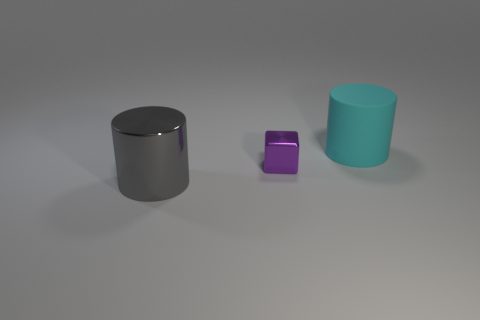Subtract all red blocks. Subtract all yellow cylinders. How many blocks are left? 1 Add 1 small cyan matte blocks. How many objects exist? 4 Subtract all blocks. How many objects are left? 2 Add 2 cylinders. How many cylinders exist? 4 Subtract 0 blue balls. How many objects are left? 3 Subtract all rubber objects. Subtract all small metal cubes. How many objects are left? 1 Add 1 metallic cylinders. How many metallic cylinders are left? 2 